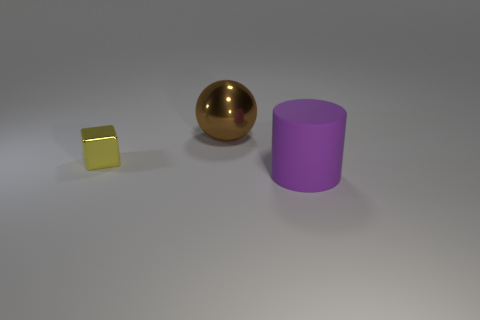Is there any other thing that has the same material as the purple thing?
Your answer should be very brief. No. What number of large objects are either yellow metallic cubes or matte cylinders?
Keep it short and to the point. 1. There is a rubber object; what shape is it?
Give a very brief answer. Cylinder. Are there any other brown things that have the same material as the small object?
Your response must be concise. Yes. Are there more big metal things than large objects?
Your answer should be compact. No. Is the material of the tiny yellow cube the same as the big cylinder?
Keep it short and to the point. No. What number of rubber objects are either big brown balls or yellow blocks?
Provide a short and direct response. 0. The object that is the same size as the cylinder is what color?
Provide a short and direct response. Brown. What number of cylinders are small blue objects or tiny yellow metal things?
Keep it short and to the point. 0. What is the material of the large cylinder?
Ensure brevity in your answer.  Rubber. 